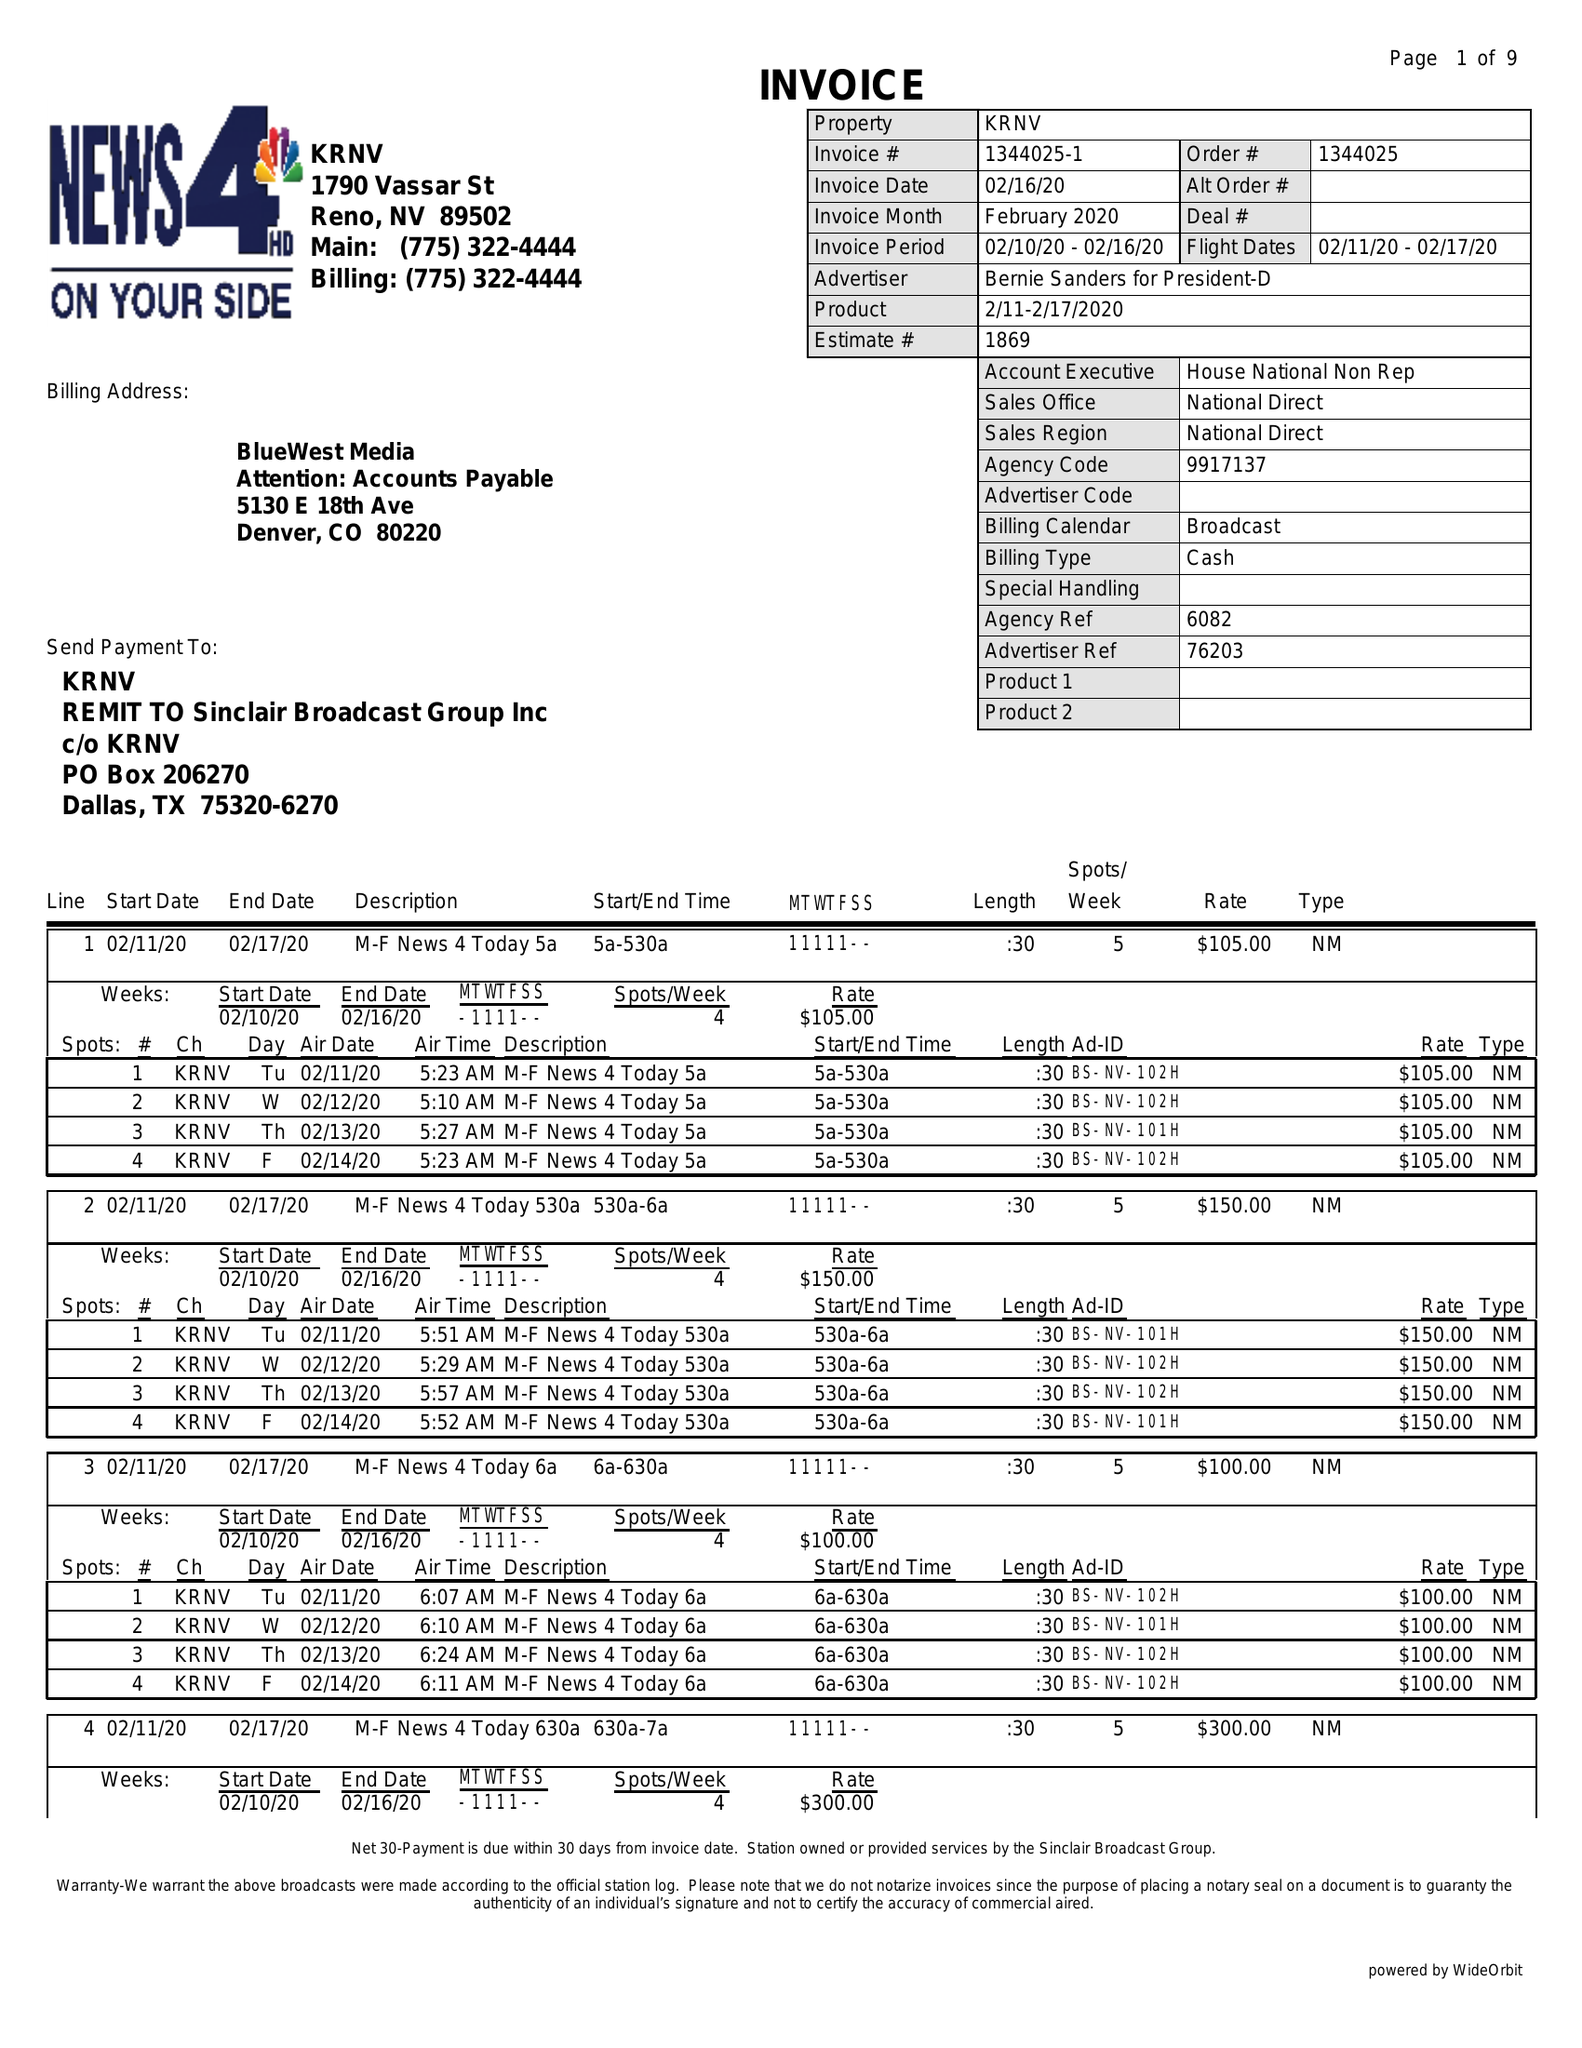What is the value for the gross_amount?
Answer the question using a single word or phrase. 29950.00 